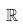Convert formula to latex. <formula><loc_0><loc_0><loc_500><loc_500>\mathbb { R }</formula> 